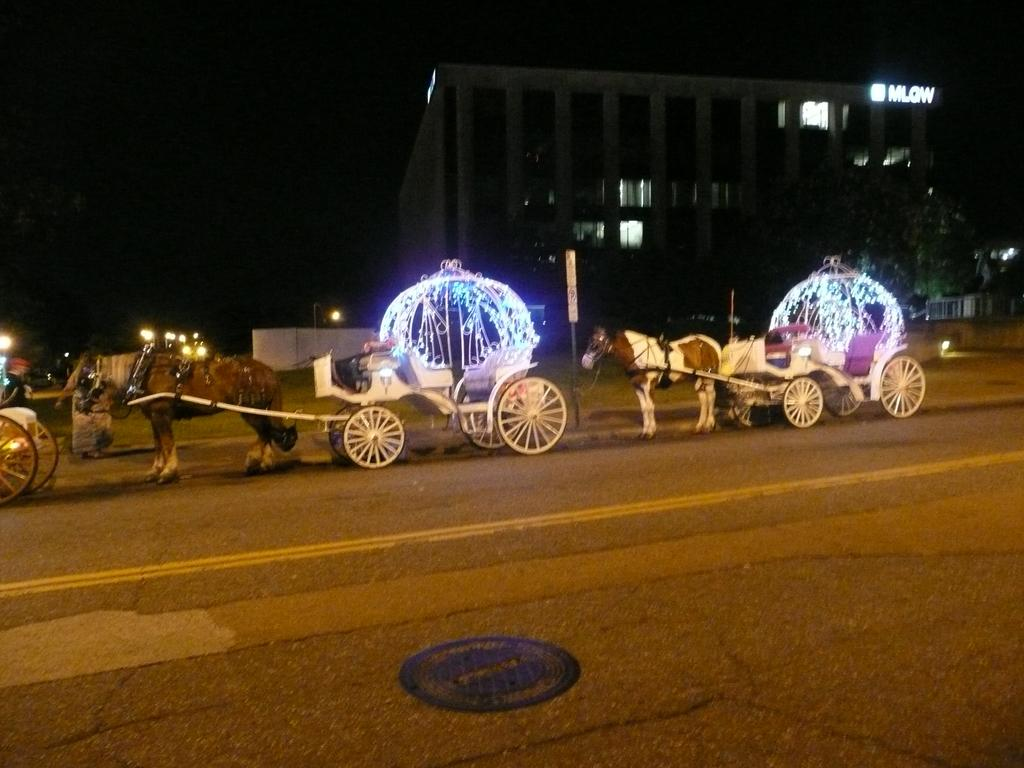What type of vehicles can be seen on the road in the image? There are horse carts on the road in the image. What structure is located in the middle of the image? There is a building in the middle of the image. What is visible at the top of the image? The sky is visible at the top of the image. What type of breath can be seen coming from the horse carts in the image? There is no text or breath visible in the image; it features horse carts on the road and a building in the middle. What type of thrill can be experienced while riding in the horse carts in the image? The image does not convey any sensations or emotions, such as thrill, as it is a static representation of horse carts on the road and a building. 